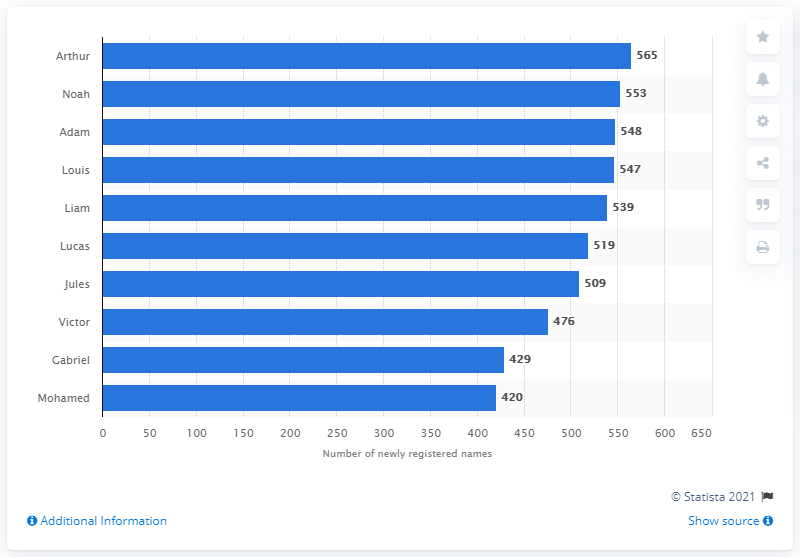Highlight a few significant elements in this photo. In 2018, the number of babies named Arthur was 565. 